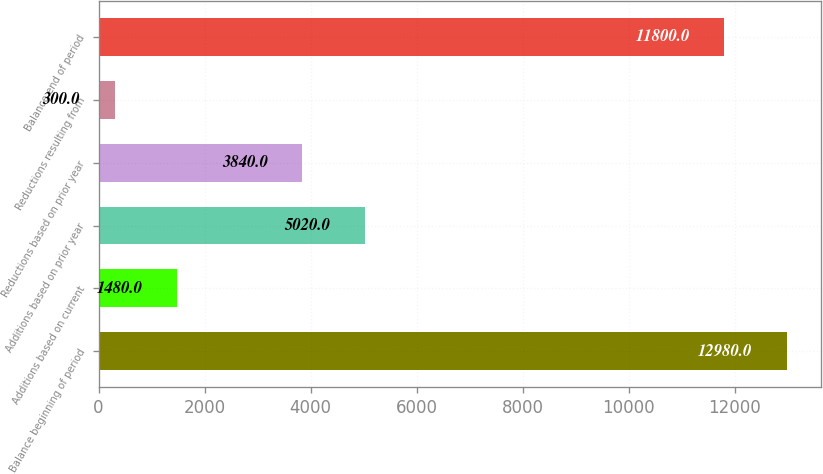<chart> <loc_0><loc_0><loc_500><loc_500><bar_chart><fcel>Balance beginning of period<fcel>Additions based on current<fcel>Additions based on prior year<fcel>Reductions based on prior year<fcel>Reductions resulting from<fcel>Balance end of period<nl><fcel>12980<fcel>1480<fcel>5020<fcel>3840<fcel>300<fcel>11800<nl></chart> 